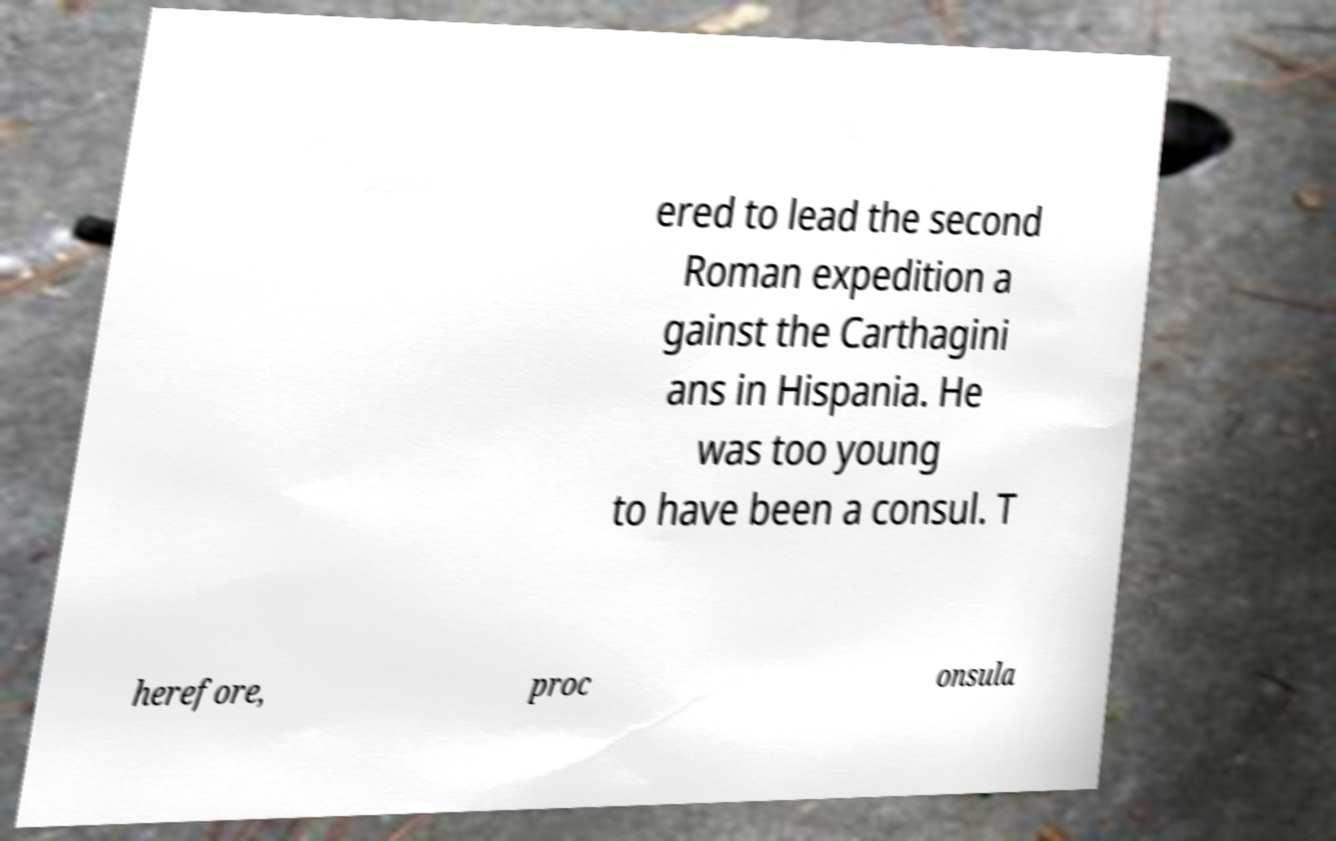I need the written content from this picture converted into text. Can you do that? ered to lead the second Roman expedition a gainst the Carthagini ans in Hispania. He was too young to have been a consul. T herefore, proc onsula 